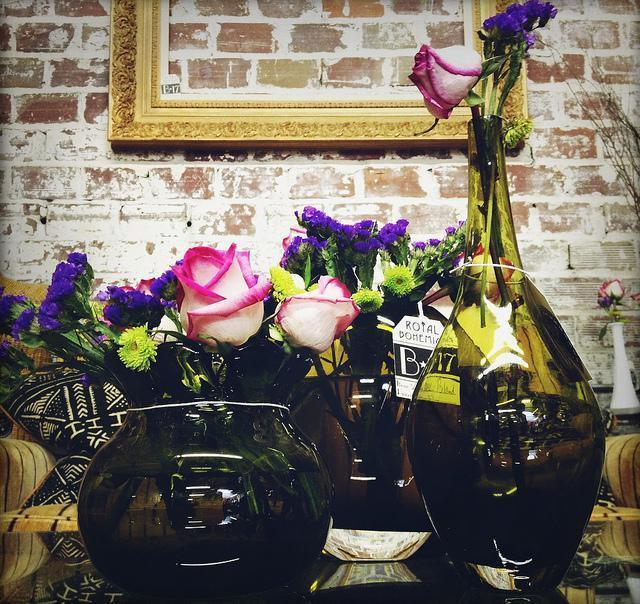How many vases are there?
Give a very brief answer. 3. How many couches can you see?
Give a very brief answer. 2. How many red bikes are there?
Give a very brief answer. 0. 